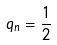<formula> <loc_0><loc_0><loc_500><loc_500>q _ { n } = \frac { 1 } { 2 }</formula> 